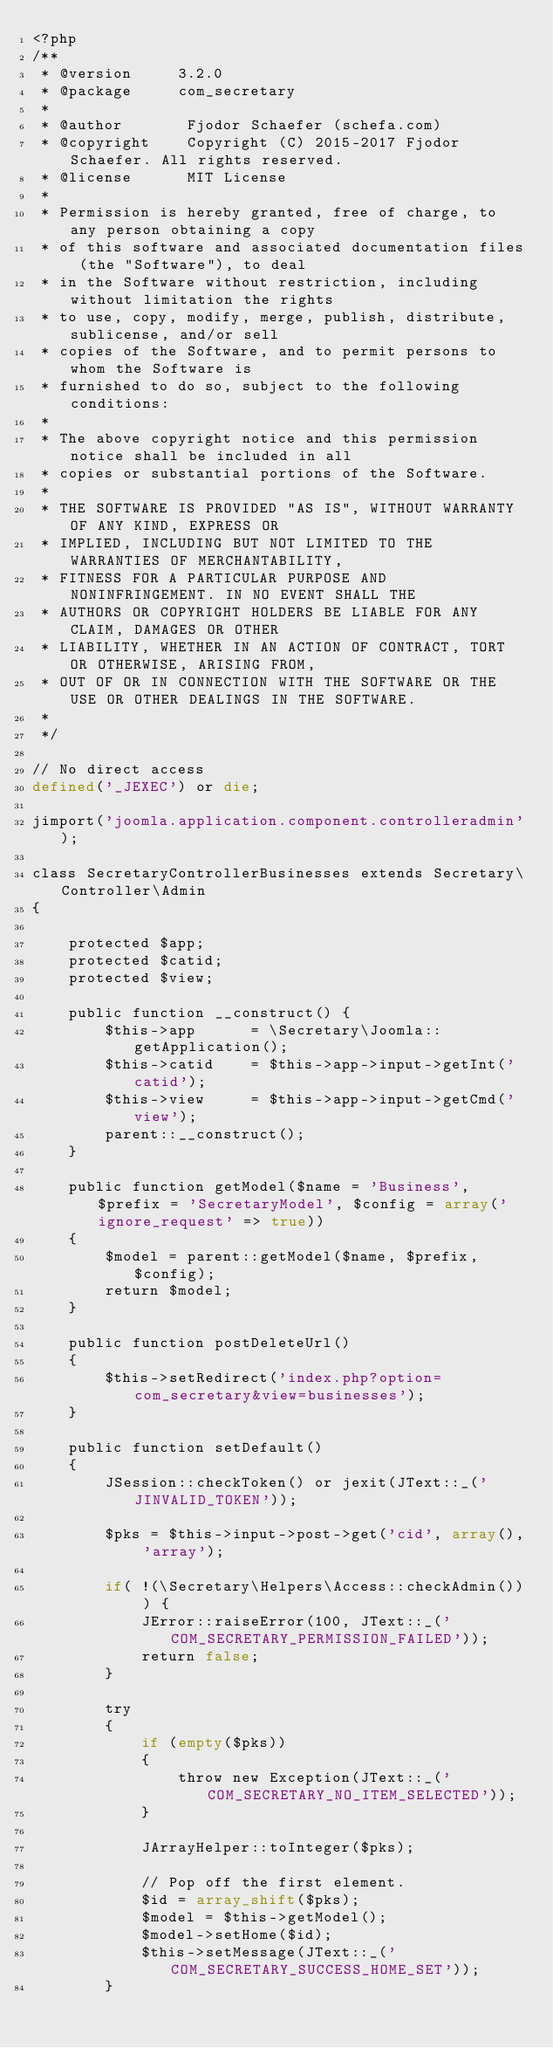<code> <loc_0><loc_0><loc_500><loc_500><_PHP_><?php
/**
 * @version     3.2.0
 * @package     com_secretary
 *
 * @author       Fjodor Schaefer (schefa.com)
 * @copyright    Copyright (C) 2015-2017 Fjodor Schaefer. All rights reserved.
 * @license      MIT License
 * 
 * Permission is hereby granted, free of charge, to any person obtaining a copy
 * of this software and associated documentation files (the "Software"), to deal
 * in the Software without restriction, including without limitation the rights
 * to use, copy, modify, merge, publish, distribute, sublicense, and/or sell
 * copies of the Software, and to permit persons to whom the Software is
 * furnished to do so, subject to the following conditions:
 * 
 * The above copyright notice and this permission notice shall be included in all
 * copies or substantial portions of the Software.
 * 
 * THE SOFTWARE IS PROVIDED "AS IS", WITHOUT WARRANTY OF ANY KIND, EXPRESS OR
 * IMPLIED, INCLUDING BUT NOT LIMITED TO THE WARRANTIES OF MERCHANTABILITY,
 * FITNESS FOR A PARTICULAR PURPOSE AND NONINFRINGEMENT. IN NO EVENT SHALL THE
 * AUTHORS OR COPYRIGHT HOLDERS BE LIABLE FOR ANY CLAIM, DAMAGES OR OTHER
 * LIABILITY, WHETHER IN AN ACTION OF CONTRACT, TORT OR OTHERWISE, ARISING FROM,
 * OUT OF OR IN CONNECTION WITH THE SOFTWARE OR THE USE OR OTHER DEALINGS IN THE SOFTWARE.
 * 
 */
 
// No direct access
defined('_JEXEC') or die;

jimport('joomla.application.component.controlleradmin'); 

class SecretaryControllerBusinesses extends Secretary\Controller\Admin
{
    
    protected $app;
    protected $catid;
    protected $view;
    
	public function __construct() {
	    $this->app		= \Secretary\Joomla::getApplication();
		$this->catid	= $this->app->input->getInt('catid');
		$this->view		= $this->app->input->getCmd('view');
		parent::__construct();
	}
	
	public function getModel($name = 'Business', $prefix = 'SecretaryModel', $config = array('ignore_request' => true))
	{
		$model = parent::getModel($name, $prefix, $config);
		return $model;
	}
	
	public function postDeleteUrl()
	{
	    $this->setRedirect('index.php?option=com_secretary&view=businesses');
	}
	
	public function setDefault()
	{
		JSession::checkToken() or jexit(JText::_('JINVALID_TOKEN'));

		$pks = $this->input->post->get('cid', array(), 'array');
		
		if( !(\Secretary\Helpers\Access::checkAdmin()) ) {
			JError::raiseError(100, JText::_('COM_SECRETARY_PERMISSION_FAILED'));
			return false;
		}
			
		try
		{
			if (empty($pks))
			{
				throw new Exception(JText::_('COM_SECRETARY_NO_ITEM_SELECTED'));
			}

			JArrayHelper::toInteger($pks);

			// Pop off the first element.
			$id = array_shift($pks);
			$model = $this->getModel();
			$model->setHome($id);
			$this->setMessage(JText::_('COM_SECRETARY_SUCCESS_HOME_SET'));
		}</code> 